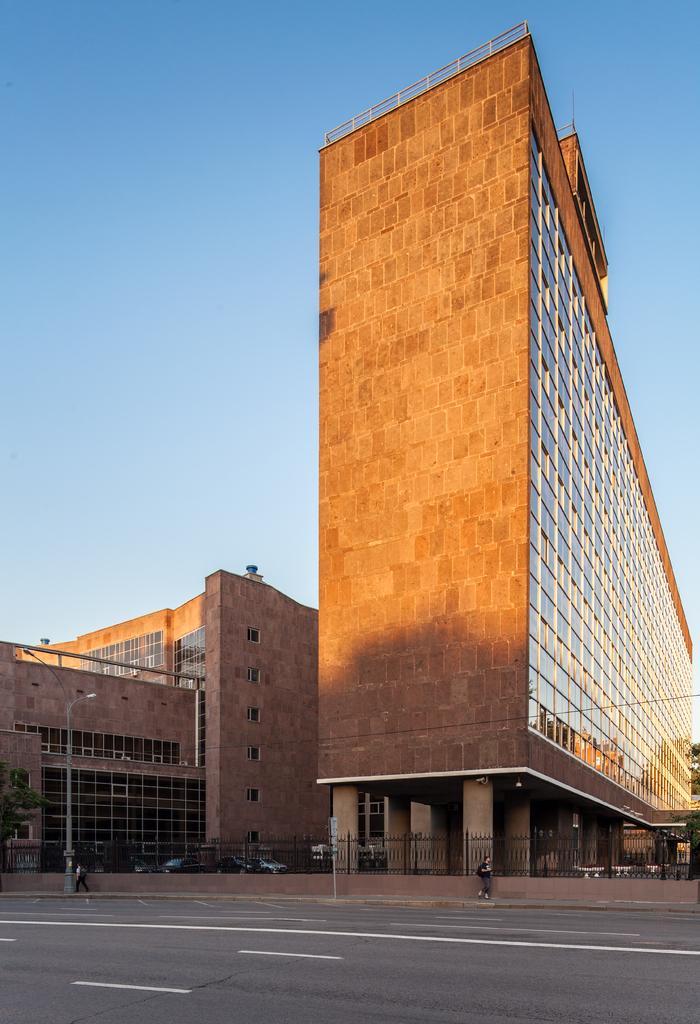Can you describe this image briefly? There are two buildings which are brown in color and there are few vehicles in between it and there is a fence wall and two persons standing beside it. 